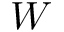Convert formula to latex. <formula><loc_0><loc_0><loc_500><loc_500>W</formula> 